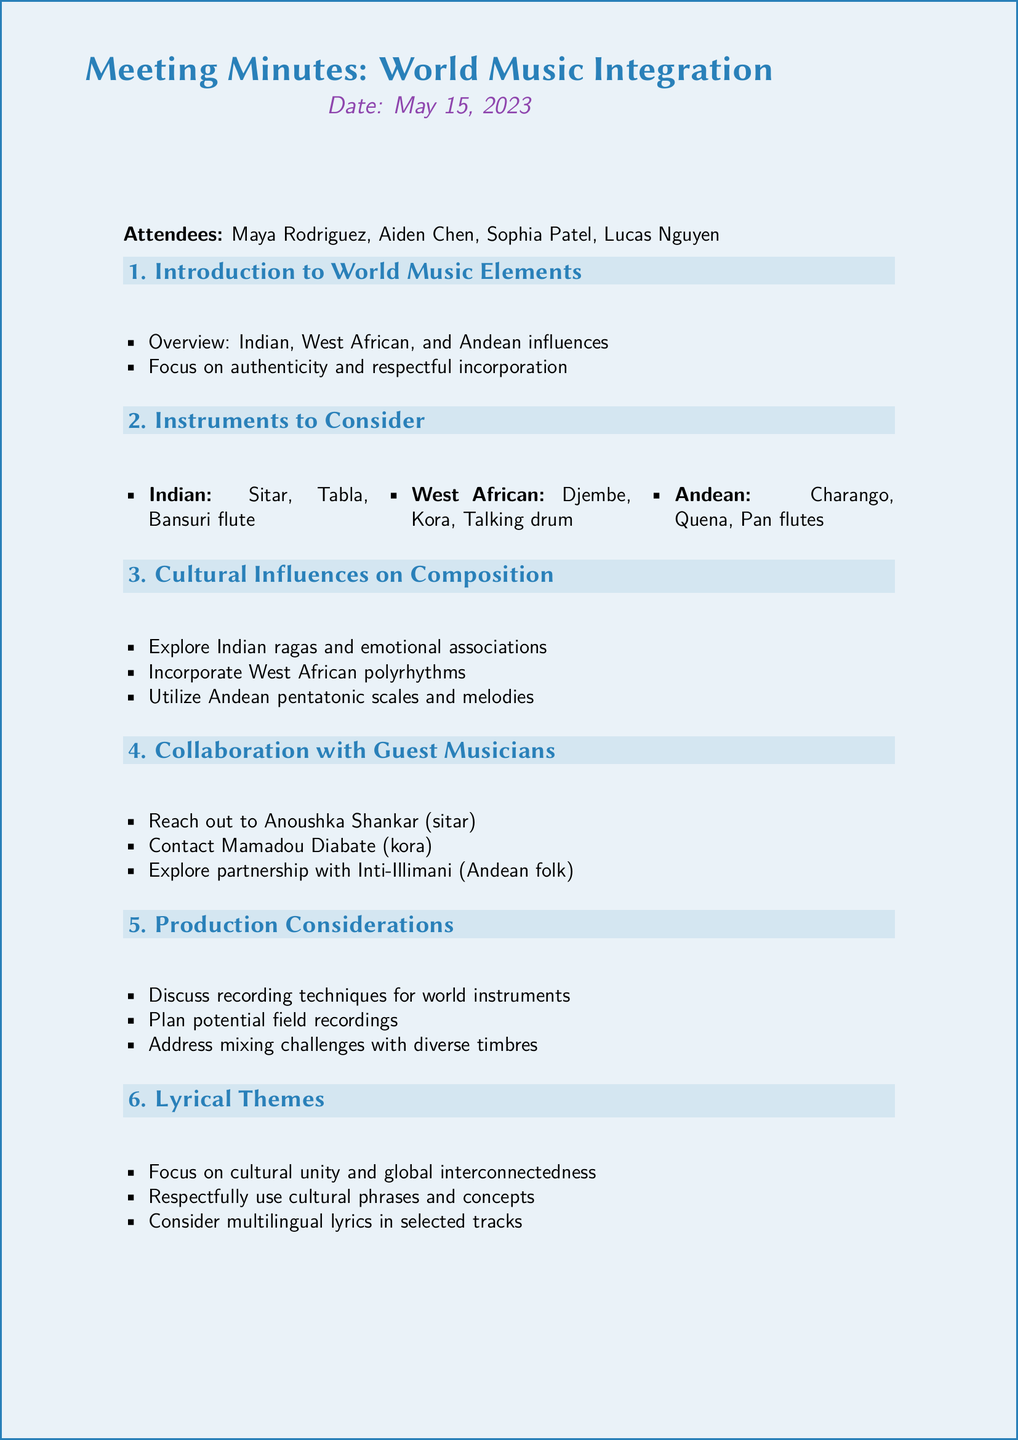What is the meeting date? The meeting date is specifically mentioned at the beginning of the document.
Answer: May 15, 2023 Who is the World Music Consultant? The name of the person serving as the World Music Consultant is listed among the attendees.
Answer: Sophia Patel What instruments are suggested from West Africa? The document lists specific instruments organized by cultural influence, including those from West Africa.
Answer: Djembe, Kora, Talking drum What is one of the lyrical themes discussed? The lyrical themes are outlined in the corresponding section of the document, referencing the focus of the themes.
Answer: Cultural unity and global interconnectedness How many attendees were present at the meeting? The total number of attendees is found in the introduction section of the document.
Answer: Four 